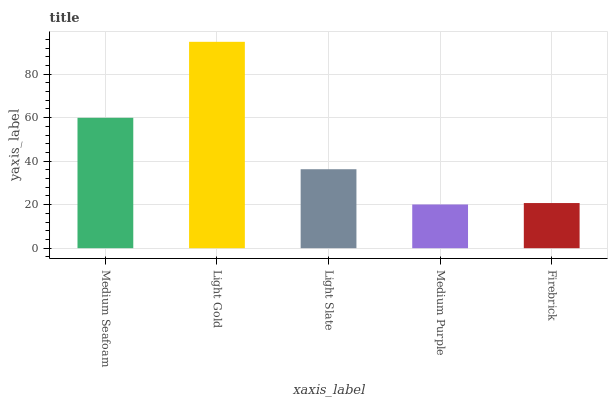Is Light Slate the minimum?
Answer yes or no. No. Is Light Slate the maximum?
Answer yes or no. No. Is Light Gold greater than Light Slate?
Answer yes or no. Yes. Is Light Slate less than Light Gold?
Answer yes or no. Yes. Is Light Slate greater than Light Gold?
Answer yes or no. No. Is Light Gold less than Light Slate?
Answer yes or no. No. Is Light Slate the high median?
Answer yes or no. Yes. Is Light Slate the low median?
Answer yes or no. Yes. Is Light Gold the high median?
Answer yes or no. No. Is Light Gold the low median?
Answer yes or no. No. 